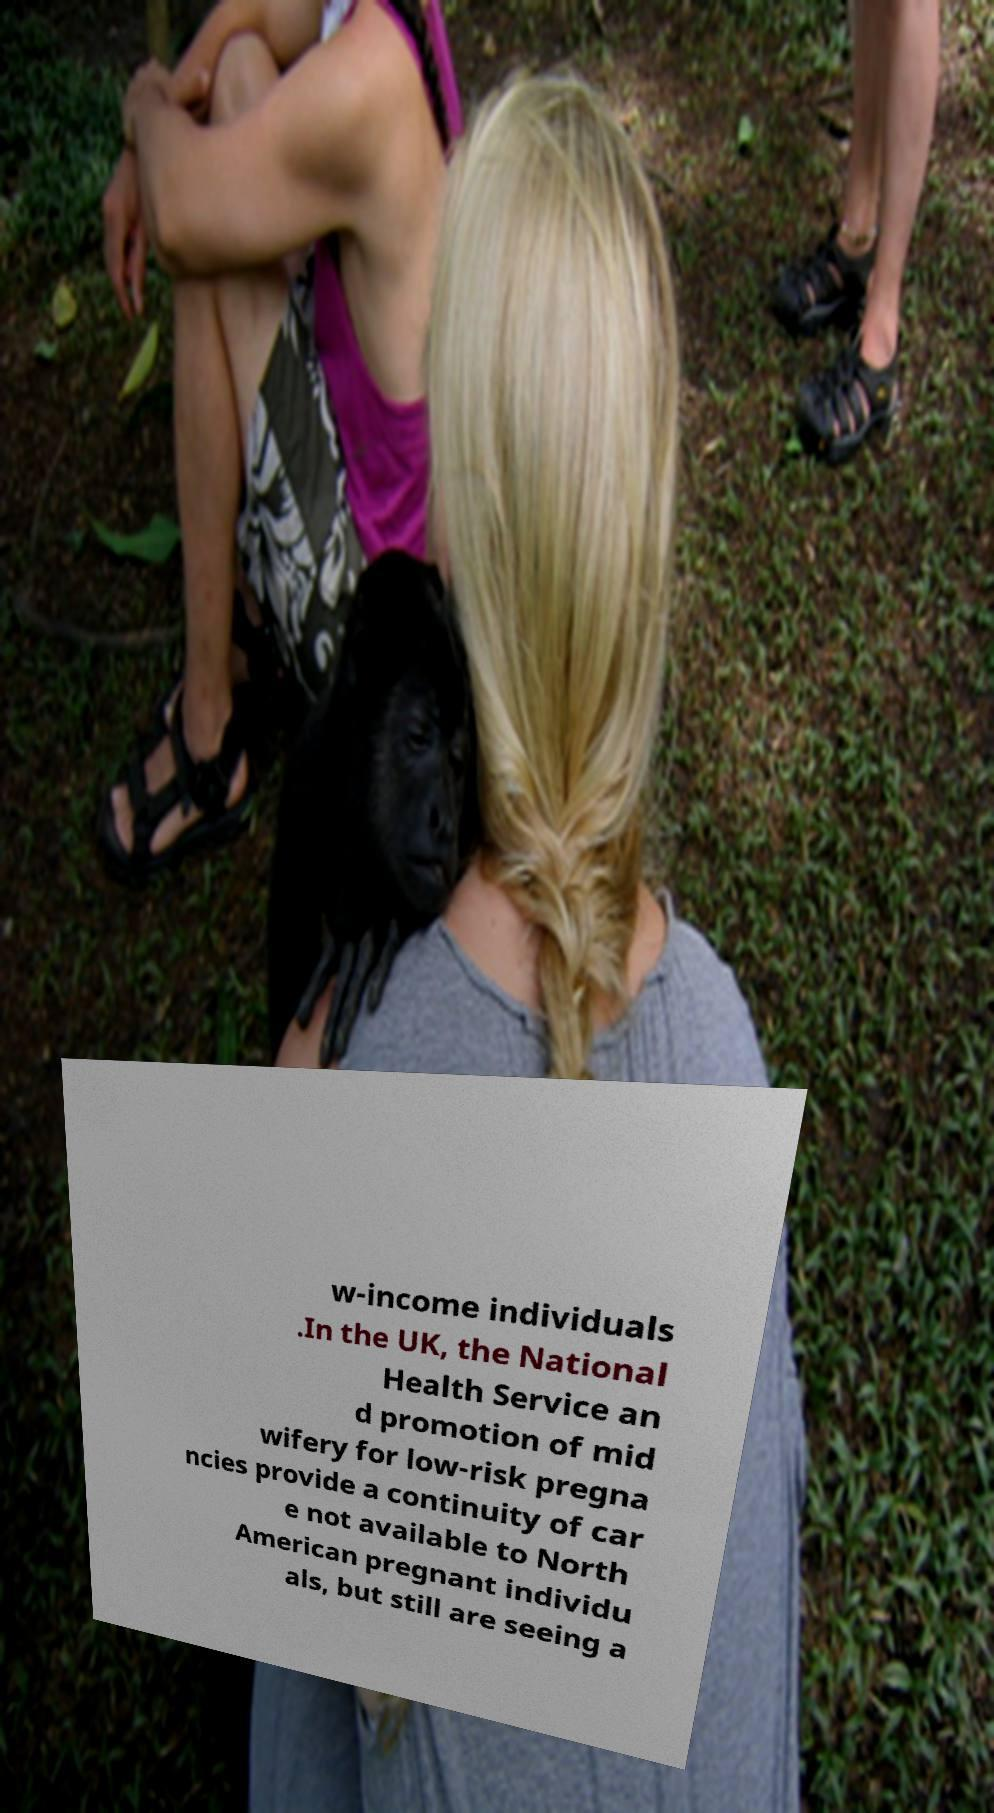Can you accurately transcribe the text from the provided image for me? w-income individuals .In the UK, the National Health Service an d promotion of mid wifery for low-risk pregna ncies provide a continuity of car e not available to North American pregnant individu als, but still are seeing a 